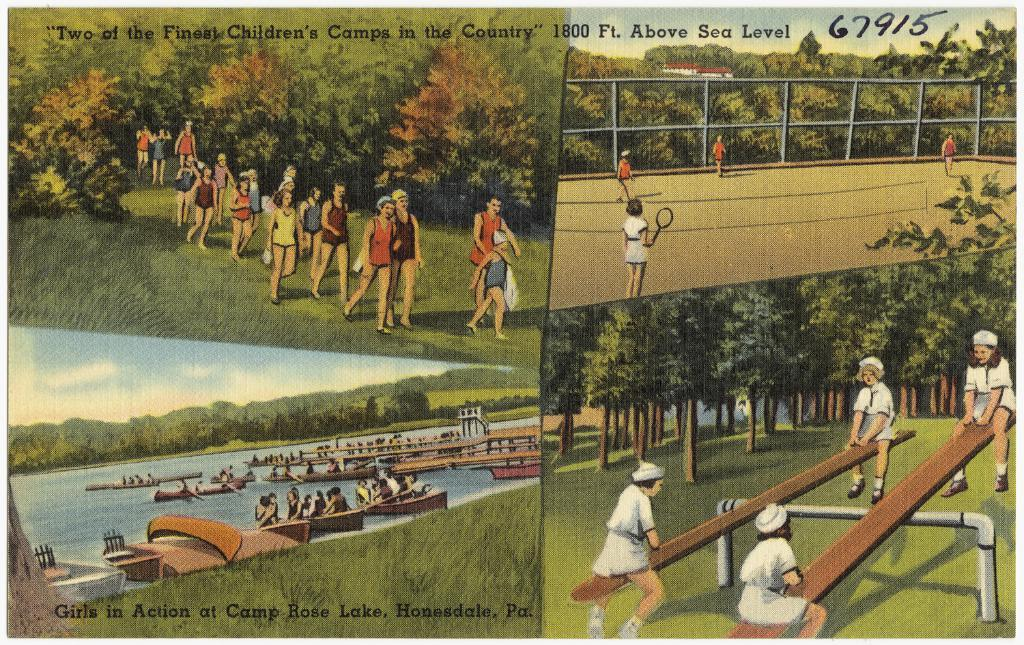<image>
Render a clear and concise summary of the photo. a painting postcard with for forviews of a camp for children 